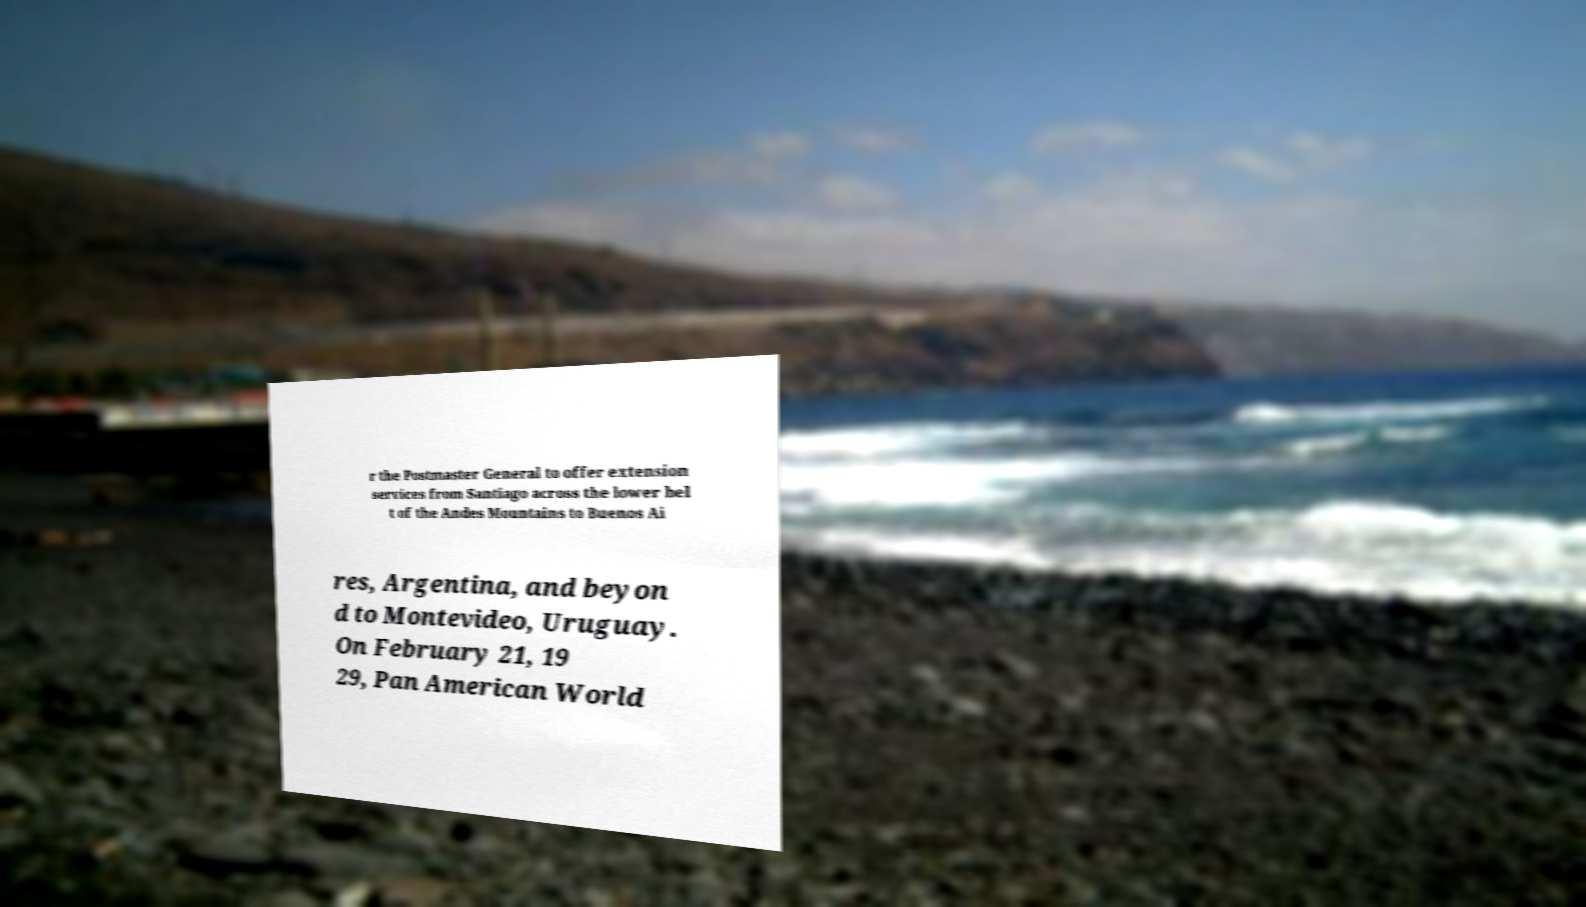Please read and relay the text visible in this image. What does it say? r the Postmaster General to offer extension services from Santiago across the lower bel t of the Andes Mountains to Buenos Ai res, Argentina, and beyon d to Montevideo, Uruguay. On February 21, 19 29, Pan American World 